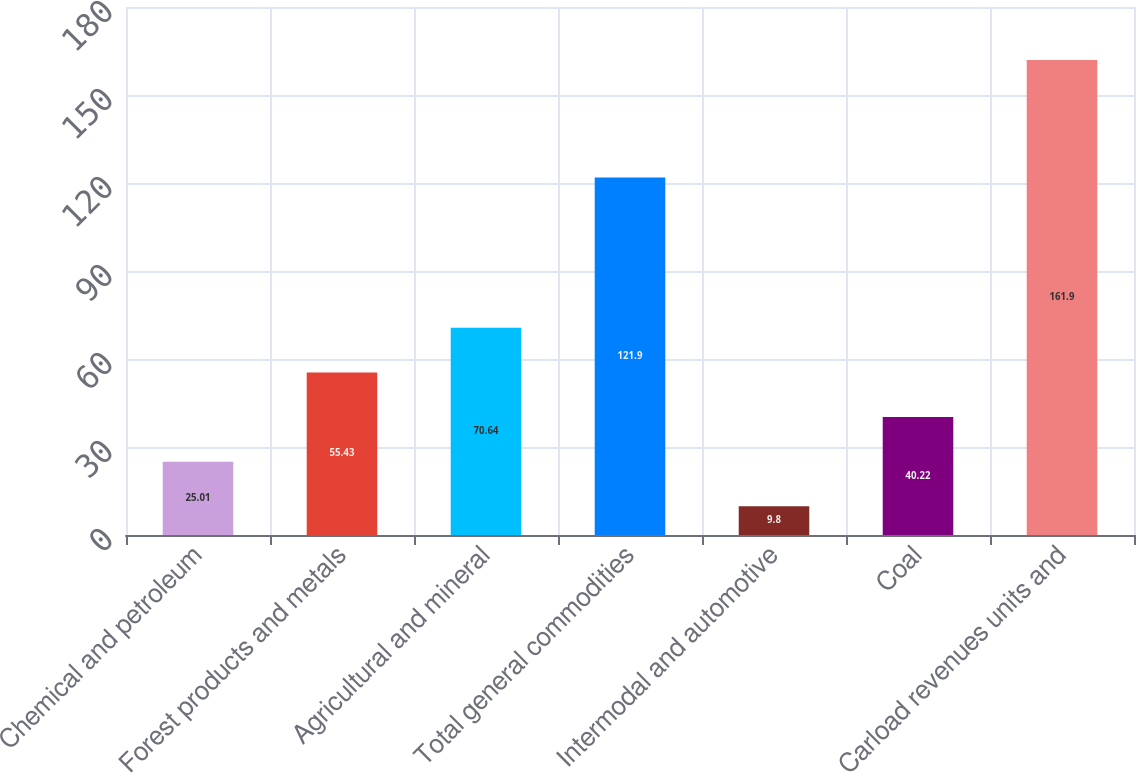Convert chart. <chart><loc_0><loc_0><loc_500><loc_500><bar_chart><fcel>Chemical and petroleum<fcel>Forest products and metals<fcel>Agricultural and mineral<fcel>Total general commodities<fcel>Intermodal and automotive<fcel>Coal<fcel>Carload revenues units and<nl><fcel>25.01<fcel>55.43<fcel>70.64<fcel>121.9<fcel>9.8<fcel>40.22<fcel>161.9<nl></chart> 